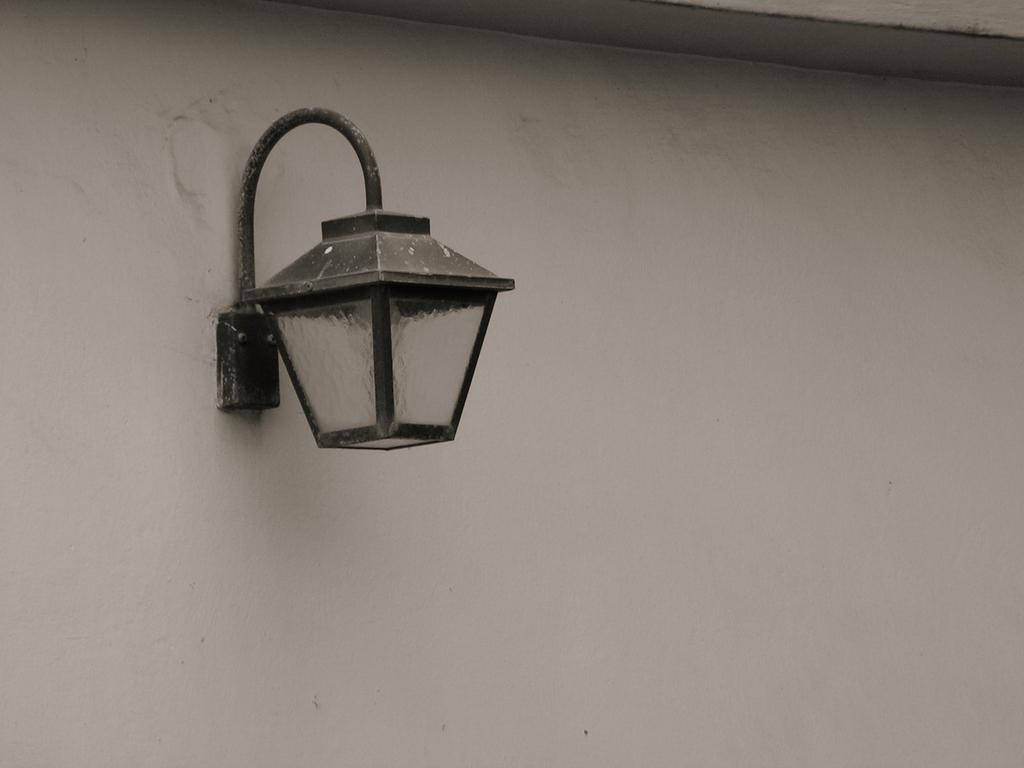What type of lighting fixture is present in the image? There is a wall lamp in the image. How is the wall lamp attached to the wall? The wall lamp is fixed to the wall. How many snails can be seen crawling on the wall lamp in the image? There are no snails present on the wall lamp in the image. What type of dust can be seen accumulating on the wall lamp in the image? There is no dust visible on the wall lamp in the image. 